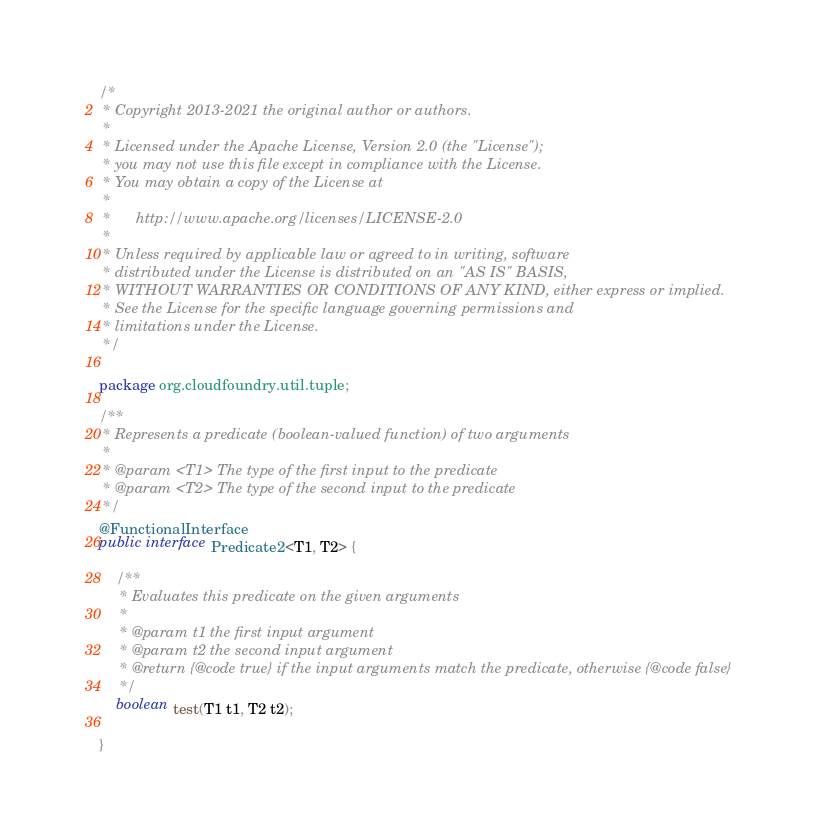Convert code to text. <code><loc_0><loc_0><loc_500><loc_500><_Java_>/*
 * Copyright 2013-2021 the original author or authors.
 *
 * Licensed under the Apache License, Version 2.0 (the "License");
 * you may not use this file except in compliance with the License.
 * You may obtain a copy of the License at
 *
 *      http://www.apache.org/licenses/LICENSE-2.0
 *
 * Unless required by applicable law or agreed to in writing, software
 * distributed under the License is distributed on an "AS IS" BASIS,
 * WITHOUT WARRANTIES OR CONDITIONS OF ANY KIND, either express or implied.
 * See the License for the specific language governing permissions and
 * limitations under the License.
 */

package org.cloudfoundry.util.tuple;

/**
 * Represents a predicate (boolean-valued function) of two arguments
 *
 * @param <T1> The type of the first input to the predicate
 * @param <T2> The type of the second input to the predicate
 */
@FunctionalInterface
public interface Predicate2<T1, T2> {

    /**
     * Evaluates this predicate on the given arguments
     *
     * @param t1 the first input argument
     * @param t2 the second input argument
     * @return {@code true} if the input arguments match the predicate, otherwise {@code false}
     */
    boolean test(T1 t1, T2 t2);

}
</code> 